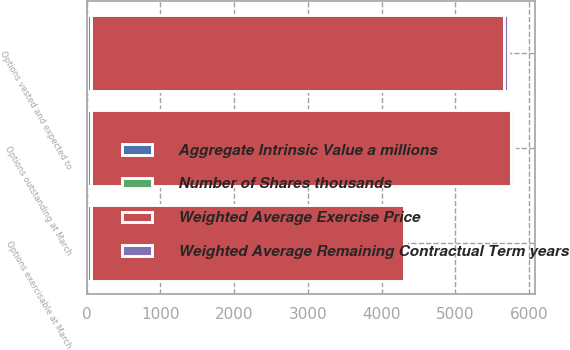Convert chart to OTSL. <chart><loc_0><loc_0><loc_500><loc_500><stacked_bar_chart><ecel><fcel>Options outstanding at March<fcel>Options vested and expected to<fcel>Options exercisable at March<nl><fcel>Weighted Average Exercise Price<fcel>5698<fcel>5611<fcel>4246<nl><fcel>Weighted Average Remaining Contractual Term years<fcel>44.22<fcel>43.97<fcel>36.22<nl><fcel>Aggregate Intrinsic Value a millions<fcel>4.8<fcel>4.8<fcel>4.4<nl><fcel>Number of Shares thousands<fcel>50<fcel>50<fcel>49.9<nl></chart> 